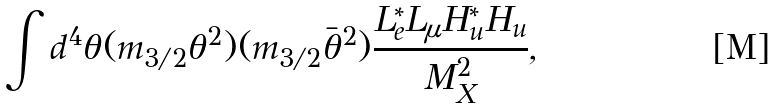<formula> <loc_0><loc_0><loc_500><loc_500>\int d ^ { 4 } \theta ( m _ { 3 / 2 } \theta ^ { 2 } ) ( m _ { 3 / 2 } \bar { \theta } ^ { 2 } ) \frac { L _ { e } ^ { * } L _ { \mu } H _ { u } ^ { * } H _ { u } } { M _ { X } ^ { 2 } } ,</formula> 